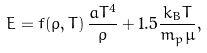<formula> <loc_0><loc_0><loc_500><loc_500>E = f ( \rho , T ) \, \frac { a T ^ { 4 } } { \rho } + 1 . 5 \frac { k _ { B } T } { m _ { p } \mu } ,</formula> 